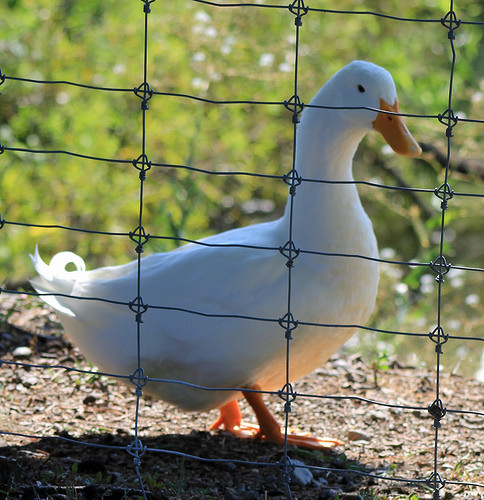<image>
Can you confirm if the duck is in front of the fence? No. The duck is not in front of the fence. The spatial positioning shows a different relationship between these objects. 